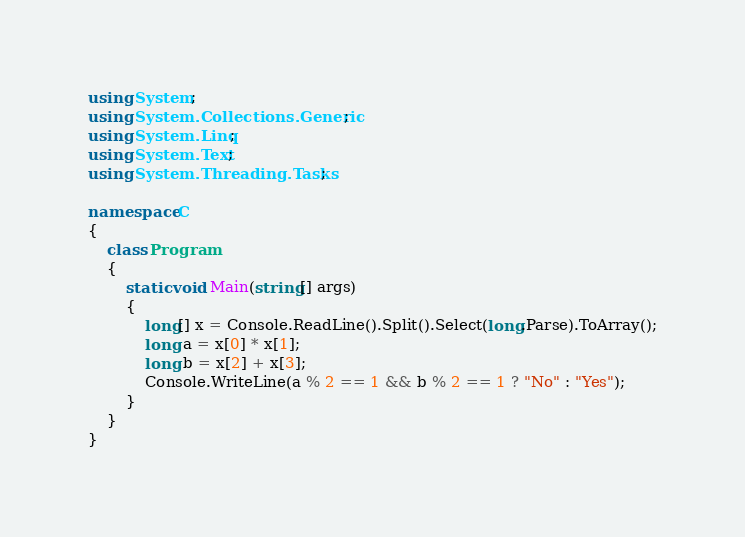Convert code to text. <code><loc_0><loc_0><loc_500><loc_500><_C#_>using System;
using System.Collections.Generic;
using System.Linq;
using System.Text;
using System.Threading.Tasks;

namespace C
{
    class Program
    {
        static void Main(string[] args)
        {
            long[] x = Console.ReadLine().Split().Select(long.Parse).ToArray();
            long a = x[0] * x[1];
            long b = x[2] + x[3];
            Console.WriteLine(a % 2 == 1 && b % 2 == 1 ? "No" : "Yes");
        }
    }
}
</code> 